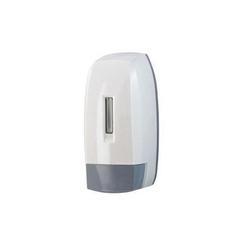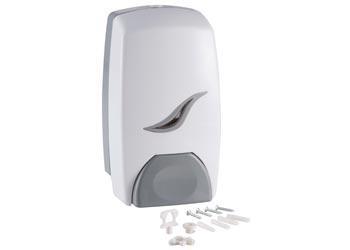The first image is the image on the left, the second image is the image on the right. For the images displayed, is the sentence "the dispenser button in the image on the left is light gray" factually correct? Answer yes or no. Yes. 